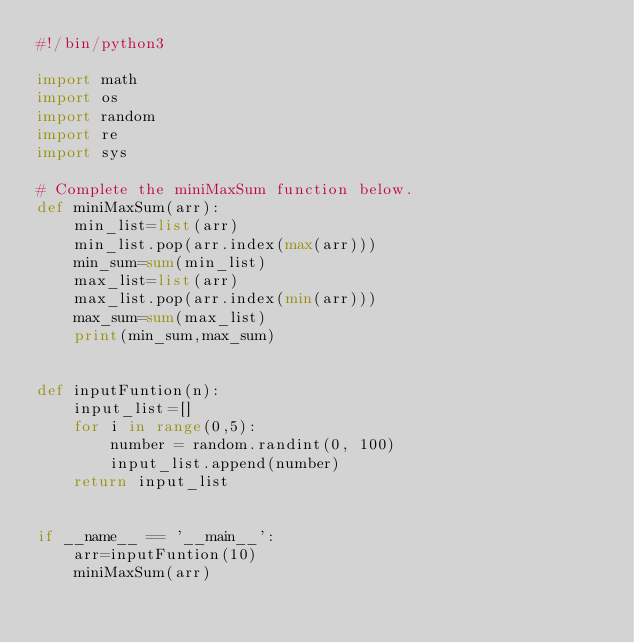<code> <loc_0><loc_0><loc_500><loc_500><_Python_>#!/bin/python3

import math
import os
import random
import re
import sys

# Complete the miniMaxSum function below.
def miniMaxSum(arr):
    min_list=list(arr)
    min_list.pop(arr.index(max(arr)))
    min_sum=sum(min_list)
    max_list=list(arr)
    max_list.pop(arr.index(min(arr)))
    max_sum=sum(max_list)
    print(min_sum,max_sum)


def inputFuntion(n):
    input_list=[]
    for i in range(0,5):
        number = random.randint(0, 100)
        input_list.append(number)
    return input_list


if __name__ == '__main__':
    arr=inputFuntion(10)
    miniMaxSum(arr)
</code> 